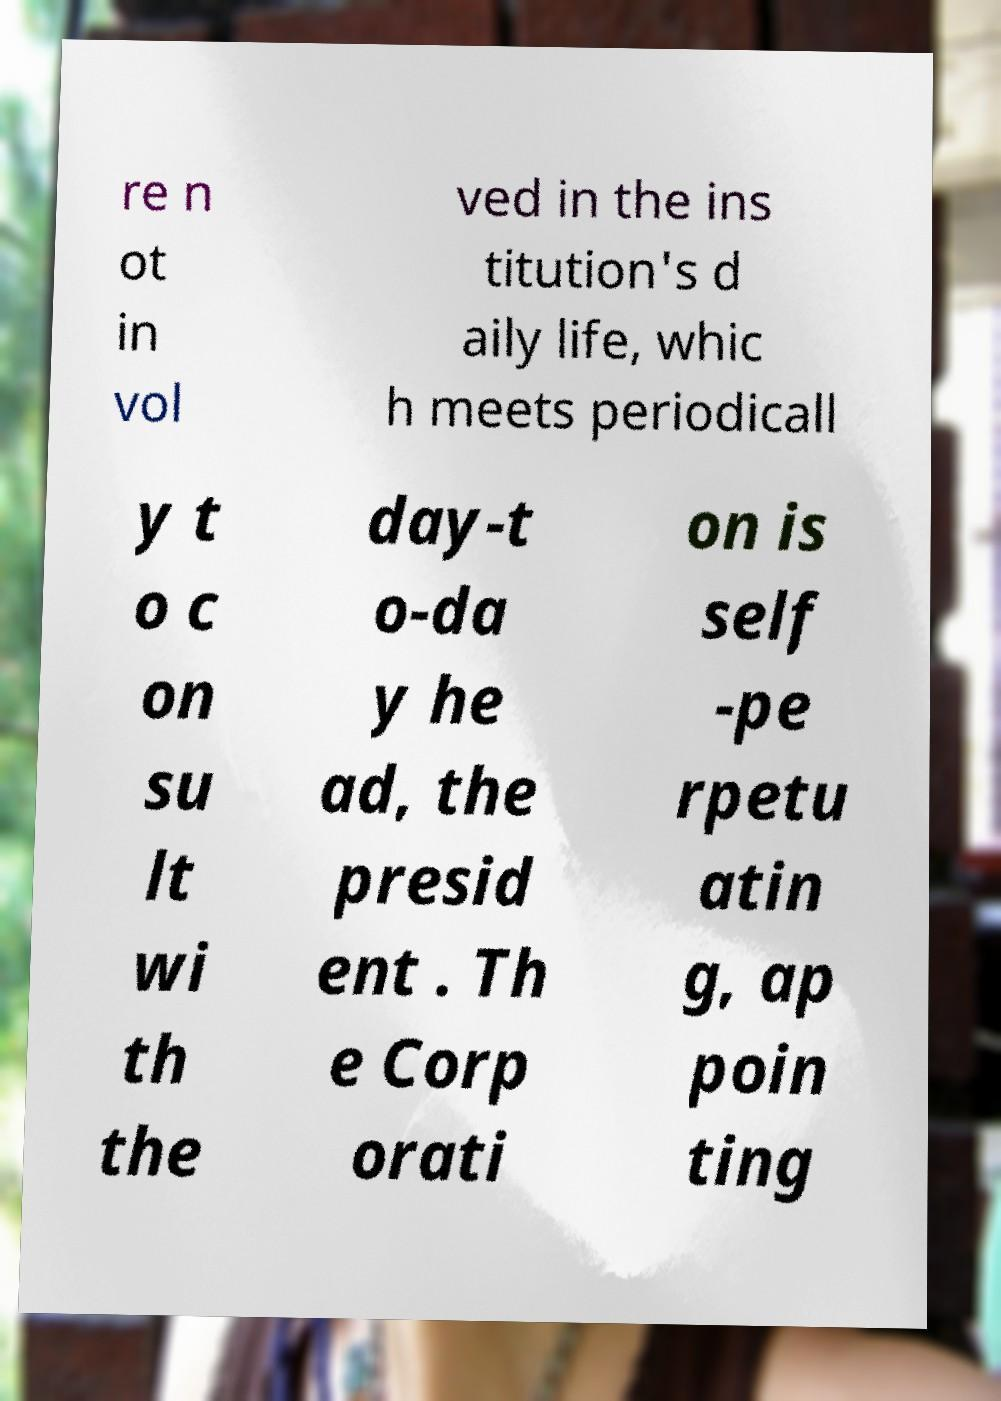What messages or text are displayed in this image? I need them in a readable, typed format. re n ot in vol ved in the ins titution's d aily life, whic h meets periodicall y t o c on su lt wi th the day-t o-da y he ad, the presid ent . Th e Corp orati on is self -pe rpetu atin g, ap poin ting 